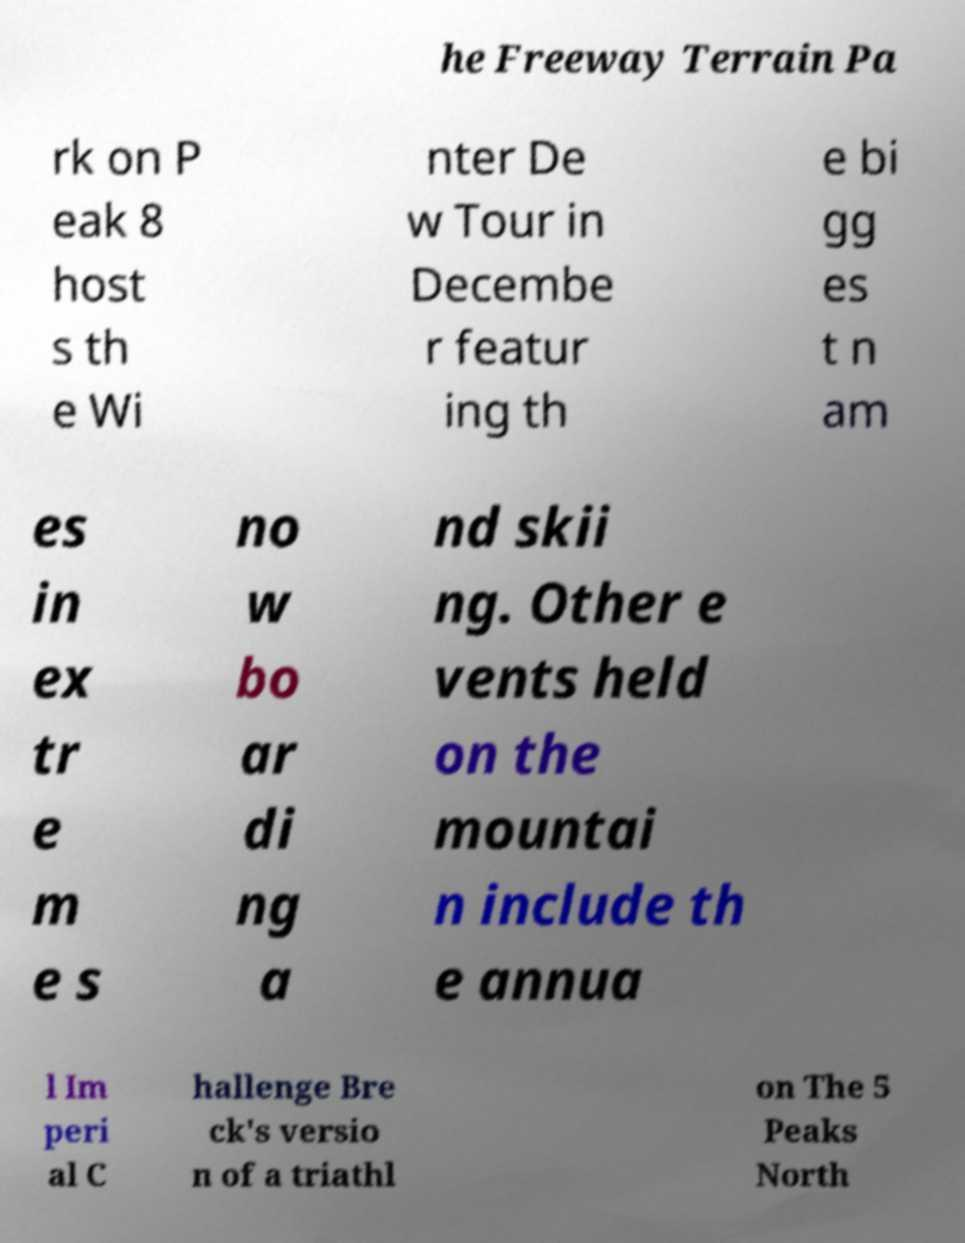Can you read and provide the text displayed in the image?This photo seems to have some interesting text. Can you extract and type it out for me? he Freeway Terrain Pa rk on P eak 8 host s th e Wi nter De w Tour in Decembe r featur ing th e bi gg es t n am es in ex tr e m e s no w bo ar di ng a nd skii ng. Other e vents held on the mountai n include th e annua l Im peri al C hallenge Bre ck's versio n of a triathl on The 5 Peaks North 